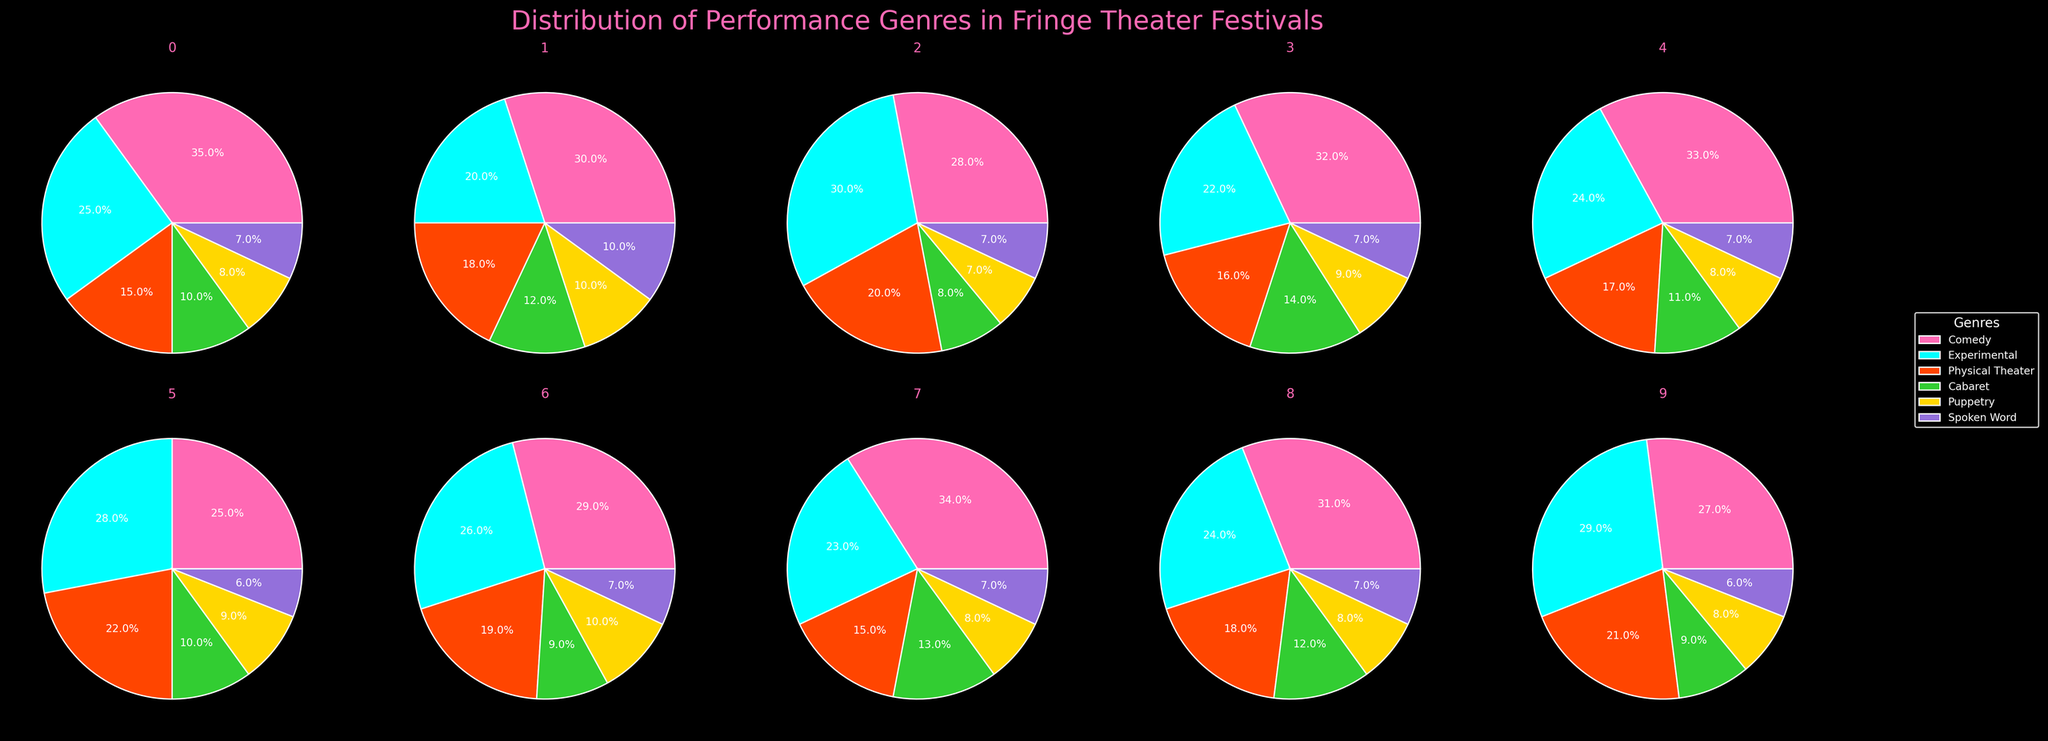What is the most common genre in the Amsterdam Fringe festival? In the pie chart for the Amsterdam Fringe (Netherlands), the largest segment, indicated by the highest percentage, represents the most common genre. The largest segment for Amsterdam Fringe is Experimental.
Answer: Experimental Which festival features the highest percentage of Physical Theater performances? To find this out, we look at each subplot and identify the percentage for the Physical Theater genre. The Avignon Off (France) has the highest percentage for Physical Theater at 22%.
Answer: Avignon Off (France) What percentage of performances in the Adelaide Fringe are devoted to Puppetry? In the pie chart for Adelaide Fringe (Australia), we look for the segment representing Puppetry and note its percentage. Puppetry accounts for 10% of performances in Adelaide Fringe.
Answer: 10% Which two festivals have an equal percentage of Spoken Word performances? We examine the percentage of Spoken Word performances in each festival's pie chart. Edinburgh Fringe (UK) and New York International Fringe (USA) both have 7% for Spoken Word performances.
Answer: Edinburgh Fringe (UK) and New York International Fringe (USA) Compare the percentage of Cabaret performances between Hollywood Fringe and Dublin Fringe. Which one has a higher percentage? By comparing the segments for Cabaret in the pie charts of Hollywood Fringe (USA) and Dublin Fringe (Ireland), we see that Hollywood Fringe has 13% and Dublin Fringe has 12%. Therefore, Hollywood Fringe has a higher percentage.
Answer: Hollywood Fringe (USA) What's the total percentage of Comedy performances in Edinburgh Fringe and Toronto Fringe combined? Add the percentages of Comedy performances in the Edinburgh Fringe (35%) and Toronto Fringe (33%). \(35 + 33 = 68\).
Answer: 68% What is the least common genre in the Bergen Fringe festival? In the pie chart for the Bergen Fringe (Norway), the segment representing the least common genre will have the smallest percentage. Spoken Word and Puppetry both have the smallest percentage at 6%.
Answer: Spoken Word/Puppetry Which festival showcases the highest variety of performance genres evenly distributed? A festival with evenly distributed performance genres will have segments of similar sizes. From the pie charts, Amsterdam Fringe (Netherlands) appears to have the most balanced distribution across all genres.
Answer: Amsterdam Fringe (Netherlands) What's the difference in percentage between Experimental performances in Avignon Off and Edinburgh Fringe? Subtract the percentage of Experimental performances in Edinburgh Fringe (25%) from those in Avignon Off (28%). \(28 - 25 = 3\).
Answer: 3% Across all festivals, which genre consistently shows a similar percentage distribution close to 10%? By examining each pie chart, it's observed that Cabaret performances consistently show a percentage close to 10% in most festivals.
Answer: Cabaret 